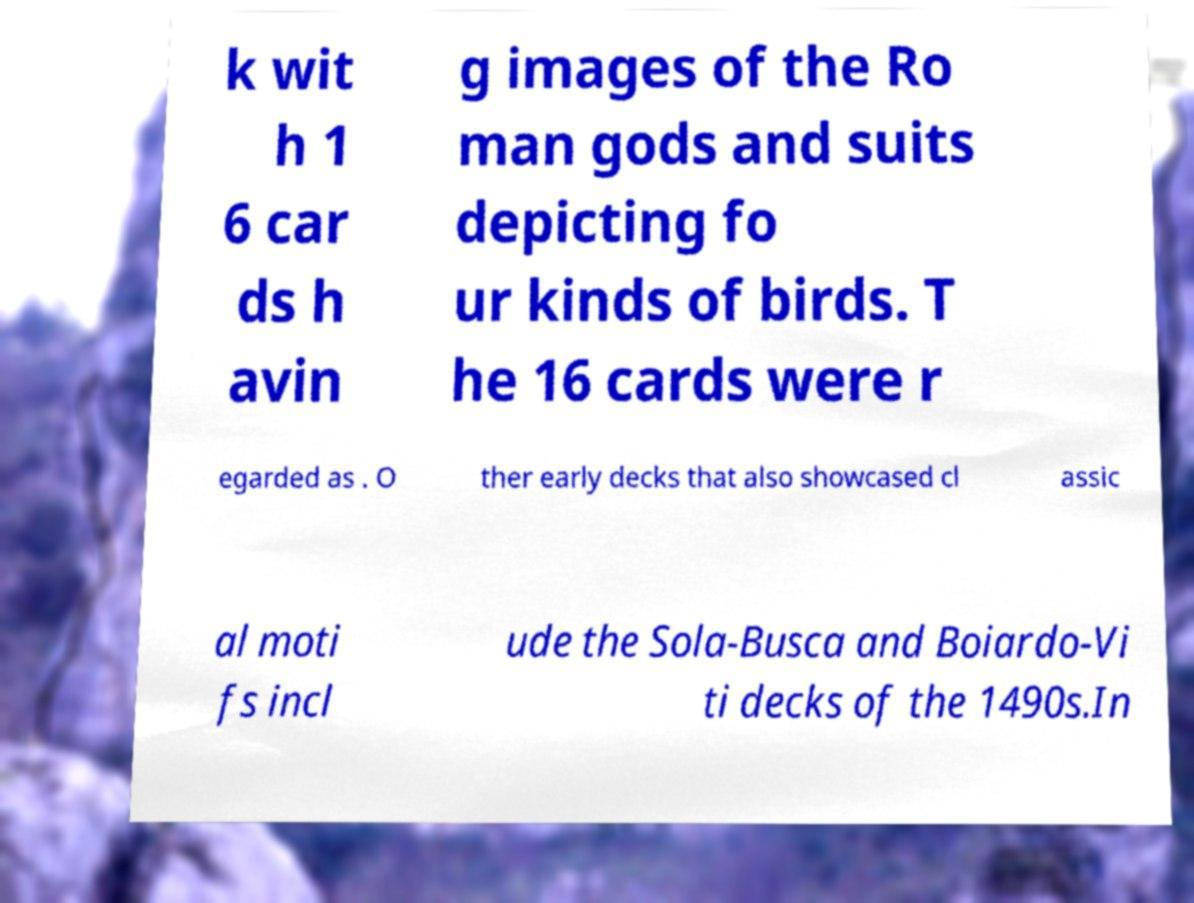Could you extract and type out the text from this image? k wit h 1 6 car ds h avin g images of the Ro man gods and suits depicting fo ur kinds of birds. T he 16 cards were r egarded as . O ther early decks that also showcased cl assic al moti fs incl ude the Sola-Busca and Boiardo-Vi ti decks of the 1490s.In 